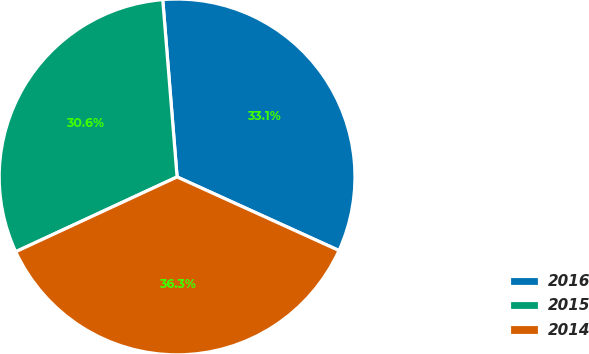Convert chart. <chart><loc_0><loc_0><loc_500><loc_500><pie_chart><fcel>2016<fcel>2015<fcel>2014<nl><fcel>33.07%<fcel>30.62%<fcel>36.3%<nl></chart> 